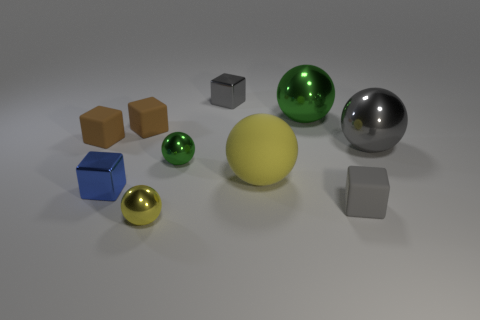There is a small shiny thing that is behind the large green shiny object; what color is it? gray 